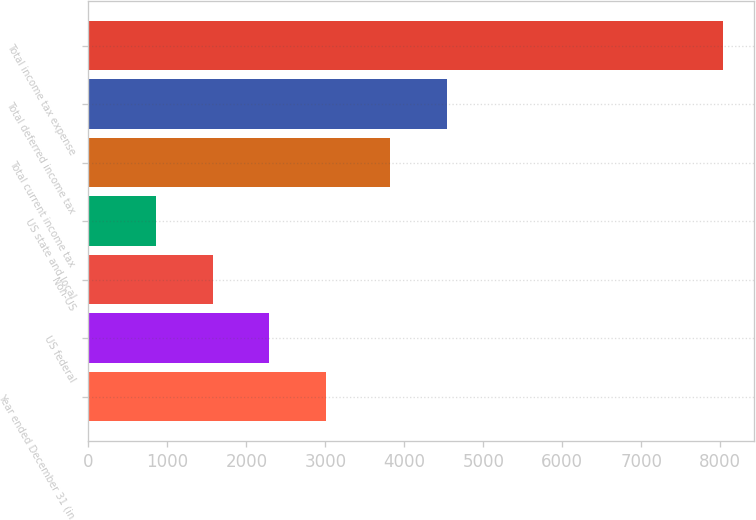Convert chart. <chart><loc_0><loc_0><loc_500><loc_500><bar_chart><fcel>Year ended December 31 (in<fcel>US federal<fcel>Non-US<fcel>US state and local<fcel>Total current income tax<fcel>Total deferred income tax<fcel>Total income tax expense<nl><fcel>3008.9<fcel>2291.6<fcel>1574.3<fcel>857<fcel>3820<fcel>4537.3<fcel>8030<nl></chart> 